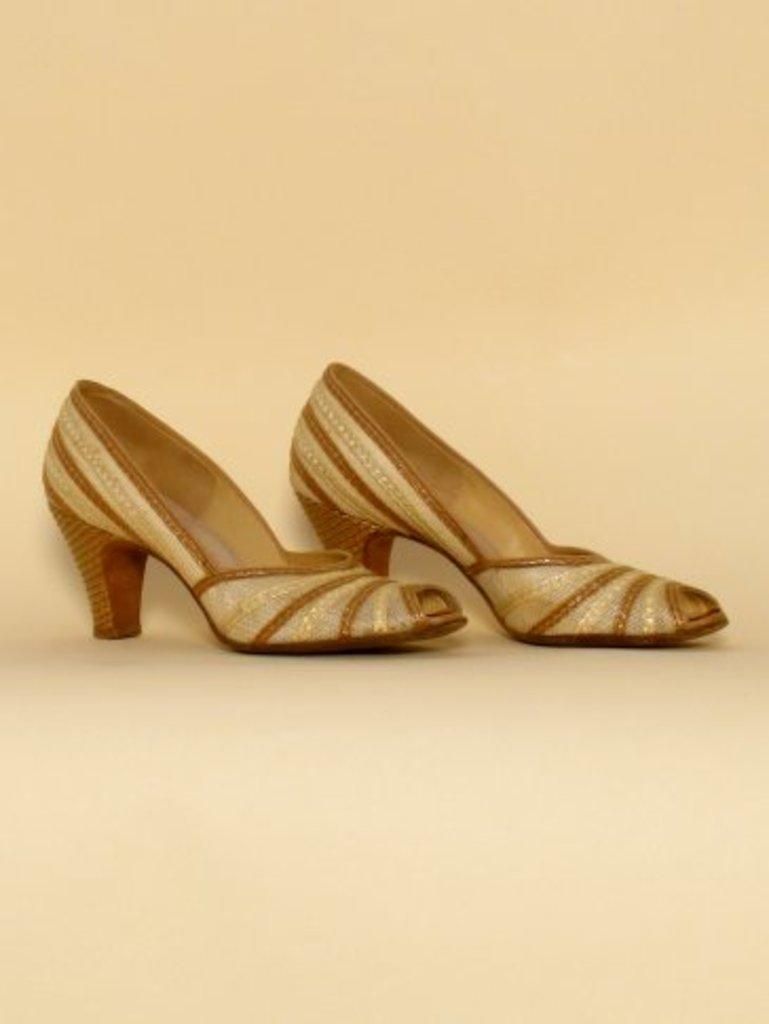What type of footwear is featured in the image? There are golden color heels in the image. What is the color of the background in the image? There is a cream color background in the image. What animals can be seen at the zoo in the image? There is no zoo or animals present in the image; it features golden color heels on a cream color background. What unit of measurement is used to determine the size of the heels in the image? The provided facts do not mention any unit of measurement for the heels, so it cannot be determined from the image. 